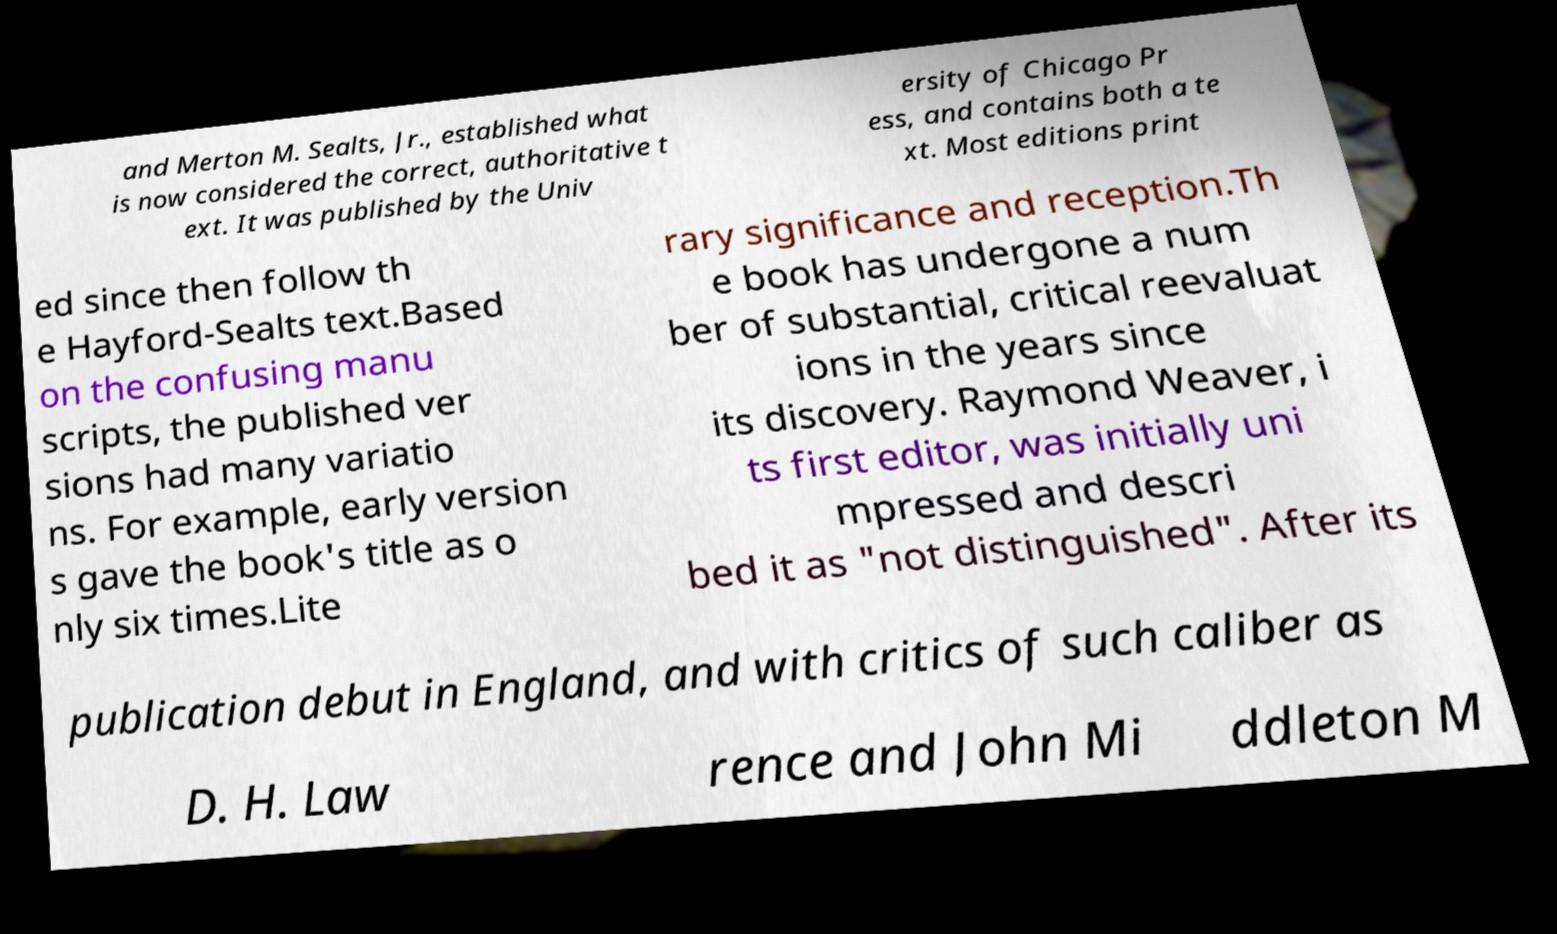Could you extract and type out the text from this image? and Merton M. Sealts, Jr., established what is now considered the correct, authoritative t ext. It was published by the Univ ersity of Chicago Pr ess, and contains both a te xt. Most editions print ed since then follow th e Hayford-Sealts text.Based on the confusing manu scripts, the published ver sions had many variatio ns. For example, early version s gave the book's title as o nly six times.Lite rary significance and reception.Th e book has undergone a num ber of substantial, critical reevaluat ions in the years since its discovery. Raymond Weaver, i ts first editor, was initially uni mpressed and descri bed it as "not distinguished". After its publication debut in England, and with critics of such caliber as D. H. Law rence and John Mi ddleton M 